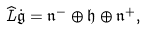<formula> <loc_0><loc_0><loc_500><loc_500>\widehat { L } \dot { \mathfrak g } = \mathfrak n ^ { - } \oplus \mathfrak h \oplus \mathfrak n ^ { + } ,</formula> 